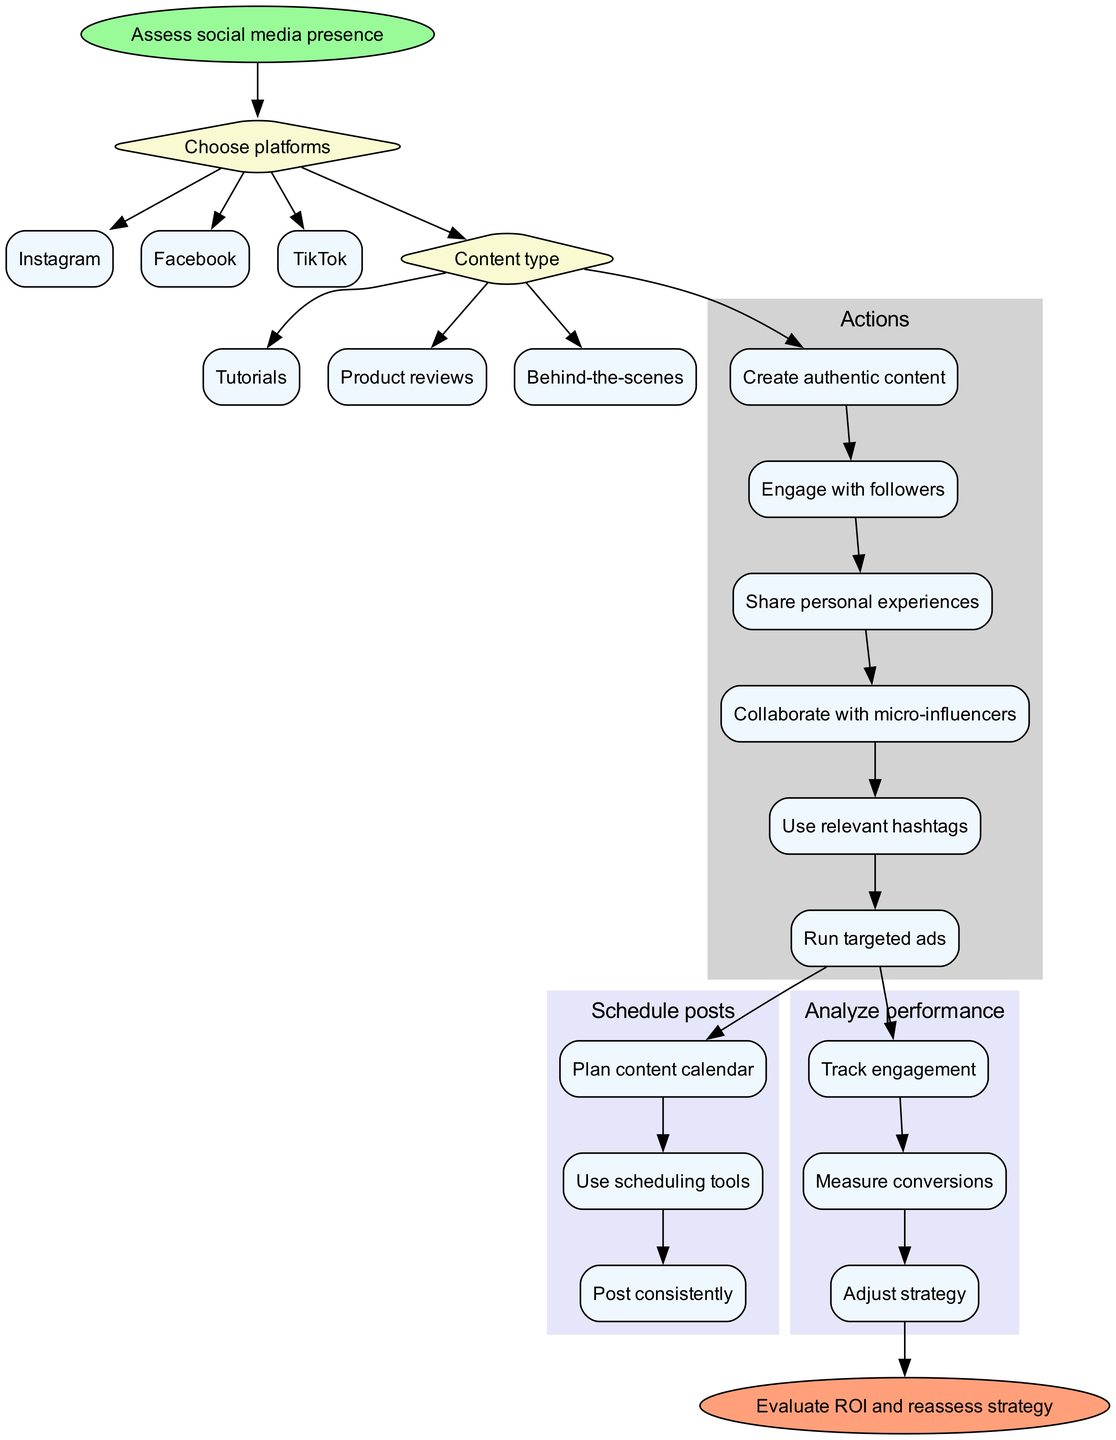What is the first step in the flowchart? The first step in the flowchart is indicated by the 'start' node, which states "Assess social media presence."
Answer: Assess social media presence How many decision nodes are in the flowchart? The flowchart contains two decision nodes: one for "Choose platforms" and another for "Content type."
Answer: 2 What are the three options for choosing platforms? The options listed under the decision node "Choose platforms" are Instagram, Facebook, and TikTok.
Answer: Instagram, Facebook, TikTok What action follows the decision "Content type"? Following the decision "Content type," the flowchart leads to the actions listed under the "Actions" section, with the first action being "Create authentic content."
Answer: Create authentic content What is the last action before the end node? The last action before reaching the end node is the subprocess "Analyze performance," specifically the last step "Adjust strategy."
Answer: Adjust strategy Which action involves collaboration? The action that involves collaboration is "Collaborate with micro-influencers."
Answer: Collaborate with micro-influencers What are the three steps in the subprocess "Schedule posts"? The subprocess "Schedule posts" includes the steps: "Plan content calendar," "Use scheduling tools," and "Post consistently."
Answer: Plan content calendar, Use scheduling tools, Post consistently How many total actions are listed in the diagram? There are a total of six actions listed in the flowchart under the "Actions" cluster.
Answer: 6 What condition leads to "Run targeted ads"? The condition that leads to "Run targeted ads" is determined by the decision node "Content type," where different content types may influence the strategy to run targeted ads.
Answer: Content type 